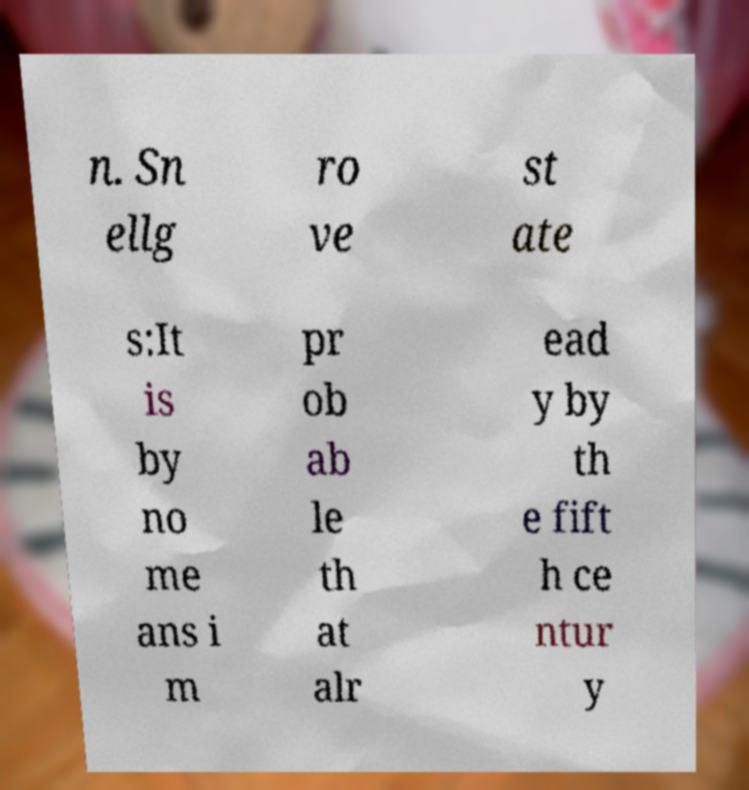I need the written content from this picture converted into text. Can you do that? n. Sn ellg ro ve st ate s:It is by no me ans i m pr ob ab le th at alr ead y by th e fift h ce ntur y 